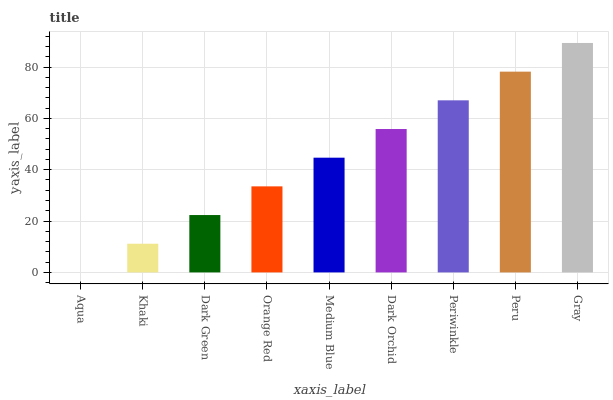Is Aqua the minimum?
Answer yes or no. Yes. Is Gray the maximum?
Answer yes or no. Yes. Is Khaki the minimum?
Answer yes or no. No. Is Khaki the maximum?
Answer yes or no. No. Is Khaki greater than Aqua?
Answer yes or no. Yes. Is Aqua less than Khaki?
Answer yes or no. Yes. Is Aqua greater than Khaki?
Answer yes or no. No. Is Khaki less than Aqua?
Answer yes or no. No. Is Medium Blue the high median?
Answer yes or no. Yes. Is Medium Blue the low median?
Answer yes or no. Yes. Is Orange Red the high median?
Answer yes or no. No. Is Aqua the low median?
Answer yes or no. No. 